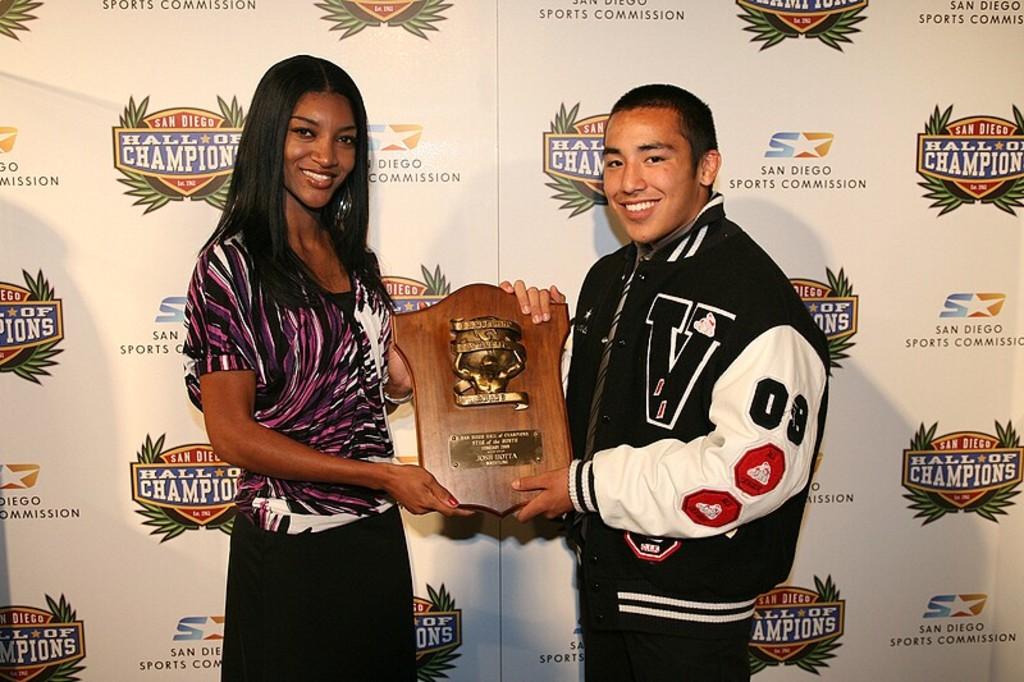What is the hall for?
Give a very brief answer. Champions. 